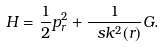<formula> <loc_0><loc_0><loc_500><loc_500>H = \frac { 1 } { 2 } p _ { r } ^ { 2 } + \frac { 1 } { \ s k ^ { 2 } ( r ) } G .</formula> 